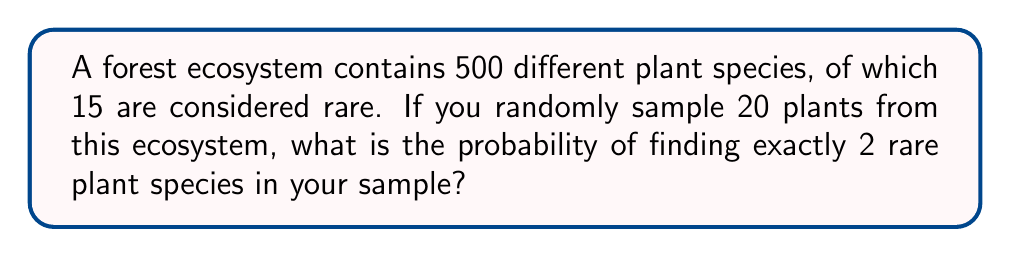What is the answer to this math problem? To solve this problem, we'll use the hypergeometric distribution, which is appropriate for sampling without replacement from a finite population.

Let's define our variables:
$N = 500$ (total number of plant species)
$K = 15$ (number of rare plant species)
$n = 20$ (sample size)
$k = 2$ (number of rare species we want to find)

The probability mass function for the hypergeometric distribution is:

$$ P(X = k) = \frac{\binom{K}{k} \binom{N-K}{n-k}}{\binom{N}{n}} $$

Step 1: Calculate $\binom{K}{k}$
$$ \binom{15}{2} = \frac{15!}{2!(15-2)!} = 105 $$

Step 2: Calculate $\binom{N-K}{n-k}$
$$ \binom{500-15}{20-2} = \binom{485}{18} = 2.0346 \times 10^{30} $$

Step 3: Calculate $\binom{N}{n}$
$$ \binom{500}{20} = 2.7028 \times 10^{32} $$

Step 4: Apply the probability mass function
$$ P(X = 2) = \frac{105 \times 2.0346 \times 10^{30}}{2.7028 \times 10^{32}} = 0.0790 $$

Therefore, the probability of finding exactly 2 rare plant species in a sample of 20 plants is approximately 0.0790 or 7.90%.
Answer: 0.0790 